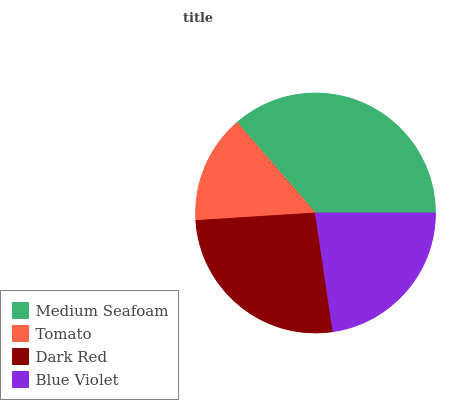Is Tomato the minimum?
Answer yes or no. Yes. Is Medium Seafoam the maximum?
Answer yes or no. Yes. Is Dark Red the minimum?
Answer yes or no. No. Is Dark Red the maximum?
Answer yes or no. No. Is Dark Red greater than Tomato?
Answer yes or no. Yes. Is Tomato less than Dark Red?
Answer yes or no. Yes. Is Tomato greater than Dark Red?
Answer yes or no. No. Is Dark Red less than Tomato?
Answer yes or no. No. Is Dark Red the high median?
Answer yes or no. Yes. Is Blue Violet the low median?
Answer yes or no. Yes. Is Medium Seafoam the high median?
Answer yes or no. No. Is Dark Red the low median?
Answer yes or no. No. 